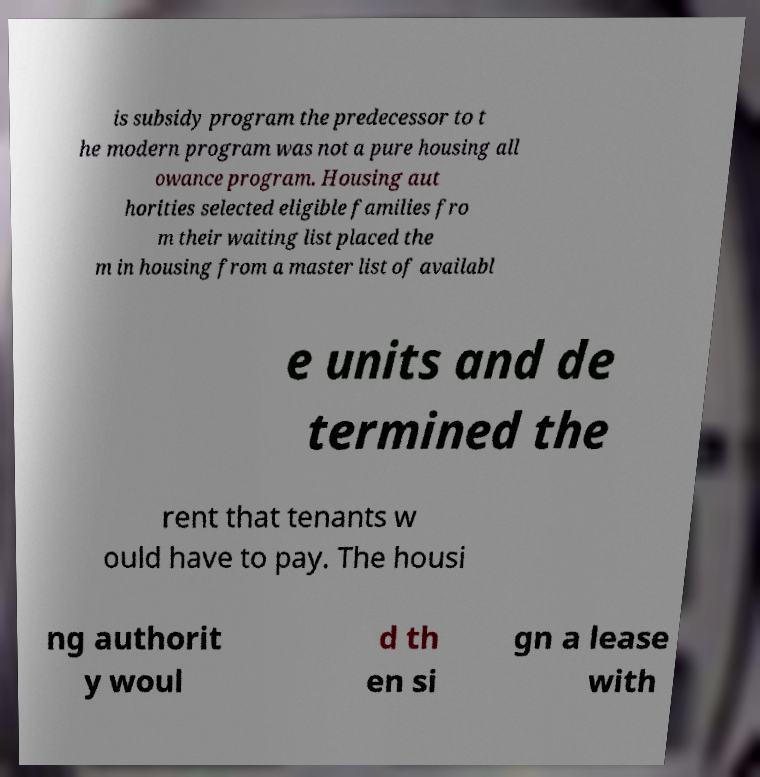Could you extract and type out the text from this image? is subsidy program the predecessor to t he modern program was not a pure housing all owance program. Housing aut horities selected eligible families fro m their waiting list placed the m in housing from a master list of availabl e units and de termined the rent that tenants w ould have to pay. The housi ng authorit y woul d th en si gn a lease with 